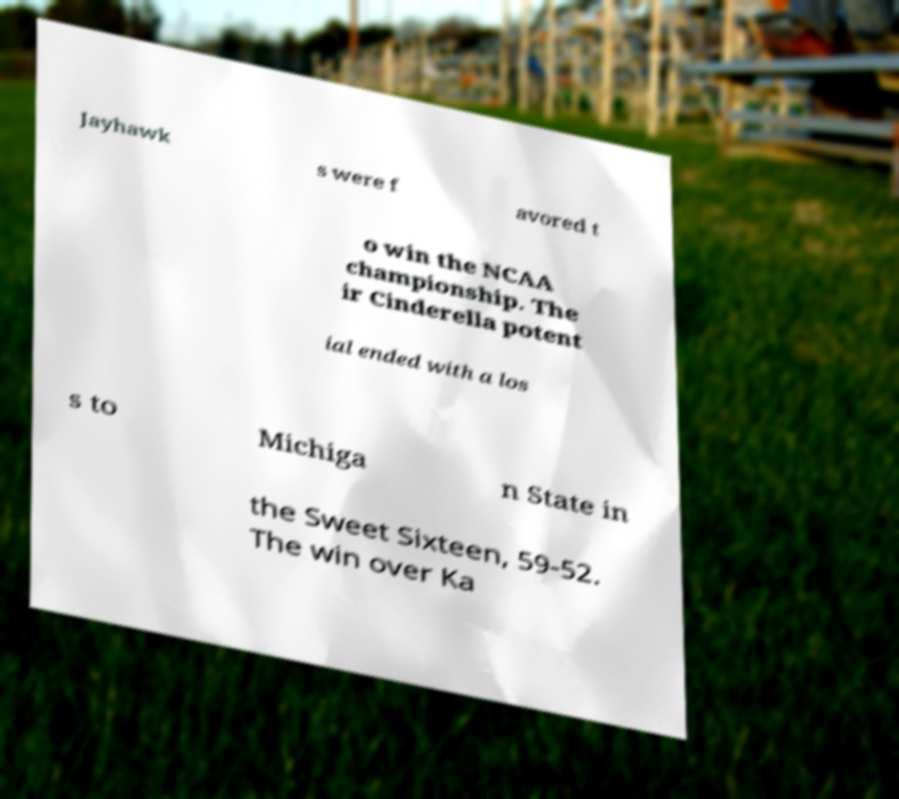Please identify and transcribe the text found in this image. Jayhawk s were f avored t o win the NCAA championship. The ir Cinderella potent ial ended with a los s to Michiga n State in the Sweet Sixteen, 59-52. The win over Ka 